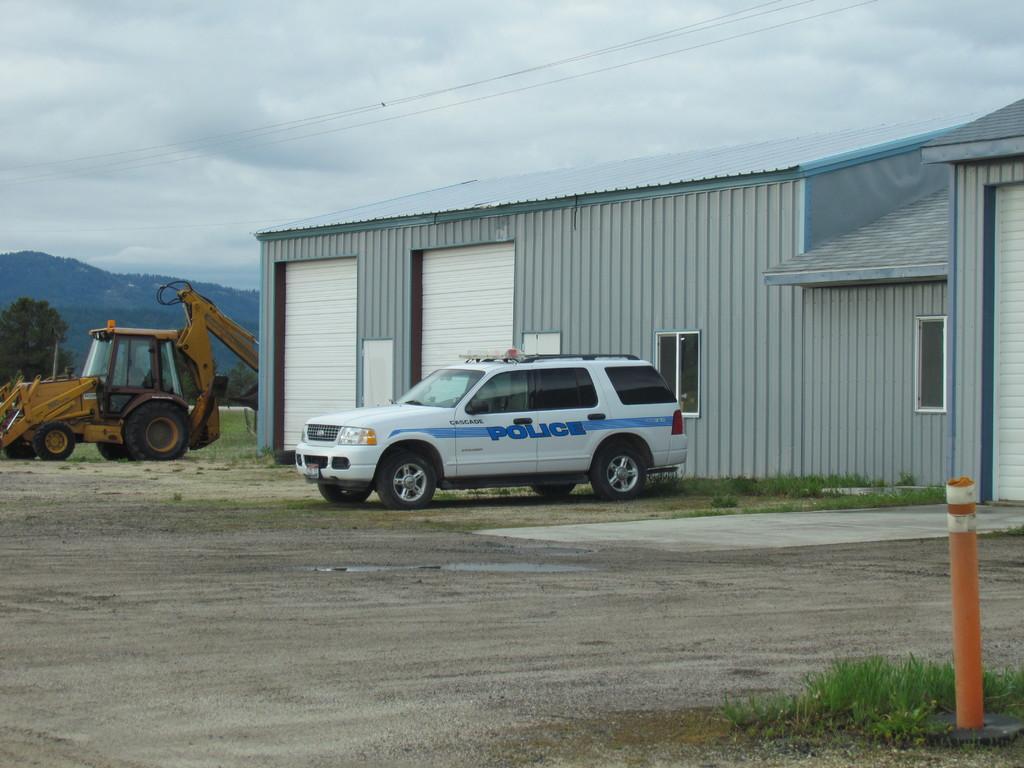Can you describe this image briefly? This image is taken outdoors. At the top of the image there is the sky with clouds. At the bottom of the image there is a ground with grass on it. In the background there are a few hills and there are a few trees. On the left side of the image a crane is parked on the ground. On the right side of the image there is a house and in the middle of the image a car is parked on the ground. 